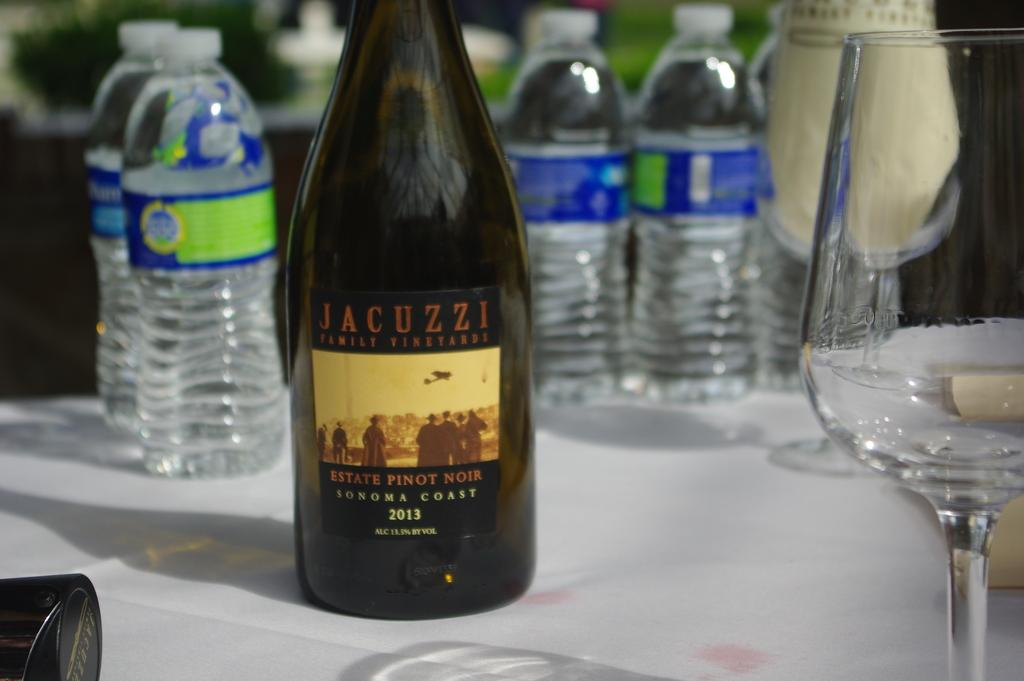What type of containers are visible in the image? There are bottles in the image. What other type of container is present in the image? There is a glass in the image. Where are the bottles and glass located? The bottles and glass are on a table. How many cakes are being transported in jail in the image? There are no cakes, transportation, or jail depicted in the image. 